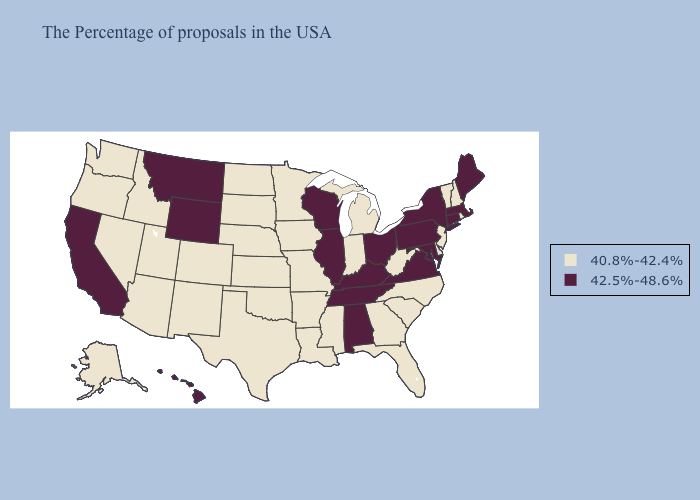Name the states that have a value in the range 40.8%-42.4%?
Answer briefly. Rhode Island, New Hampshire, Vermont, New Jersey, Delaware, North Carolina, South Carolina, West Virginia, Florida, Georgia, Michigan, Indiana, Mississippi, Louisiana, Missouri, Arkansas, Minnesota, Iowa, Kansas, Nebraska, Oklahoma, Texas, South Dakota, North Dakota, Colorado, New Mexico, Utah, Arizona, Idaho, Nevada, Washington, Oregon, Alaska. Does New Mexico have the highest value in the West?
Be succinct. No. Does Tennessee have a lower value than Georgia?
Quick response, please. No. What is the highest value in the MidWest ?
Answer briefly. 42.5%-48.6%. Does New Jersey have the same value as Ohio?
Give a very brief answer. No. Does Kentucky have the highest value in the South?
Short answer required. Yes. What is the lowest value in states that border Rhode Island?
Quick response, please. 42.5%-48.6%. Which states have the lowest value in the Northeast?
Short answer required. Rhode Island, New Hampshire, Vermont, New Jersey. Which states have the lowest value in the MidWest?
Keep it brief. Michigan, Indiana, Missouri, Minnesota, Iowa, Kansas, Nebraska, South Dakota, North Dakota. What is the lowest value in the USA?
Keep it brief. 40.8%-42.4%. Which states have the lowest value in the USA?
Concise answer only. Rhode Island, New Hampshire, Vermont, New Jersey, Delaware, North Carolina, South Carolina, West Virginia, Florida, Georgia, Michigan, Indiana, Mississippi, Louisiana, Missouri, Arkansas, Minnesota, Iowa, Kansas, Nebraska, Oklahoma, Texas, South Dakota, North Dakota, Colorado, New Mexico, Utah, Arizona, Idaho, Nevada, Washington, Oregon, Alaska. Name the states that have a value in the range 40.8%-42.4%?
Concise answer only. Rhode Island, New Hampshire, Vermont, New Jersey, Delaware, North Carolina, South Carolina, West Virginia, Florida, Georgia, Michigan, Indiana, Mississippi, Louisiana, Missouri, Arkansas, Minnesota, Iowa, Kansas, Nebraska, Oklahoma, Texas, South Dakota, North Dakota, Colorado, New Mexico, Utah, Arizona, Idaho, Nevada, Washington, Oregon, Alaska. What is the value of Michigan?
Give a very brief answer. 40.8%-42.4%. Among the states that border Pennsylvania , which have the highest value?
Quick response, please. New York, Maryland, Ohio. Which states hav the highest value in the Northeast?
Answer briefly. Maine, Massachusetts, Connecticut, New York, Pennsylvania. 